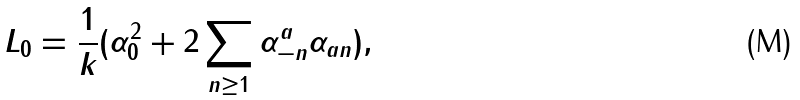Convert formula to latex. <formula><loc_0><loc_0><loc_500><loc_500>L _ { 0 } = \frac { 1 } { k } ( \alpha _ { 0 } ^ { 2 } + 2 \sum _ { n \geq 1 } \alpha ^ { a } _ { - n } \alpha _ { a n } ) ,</formula> 